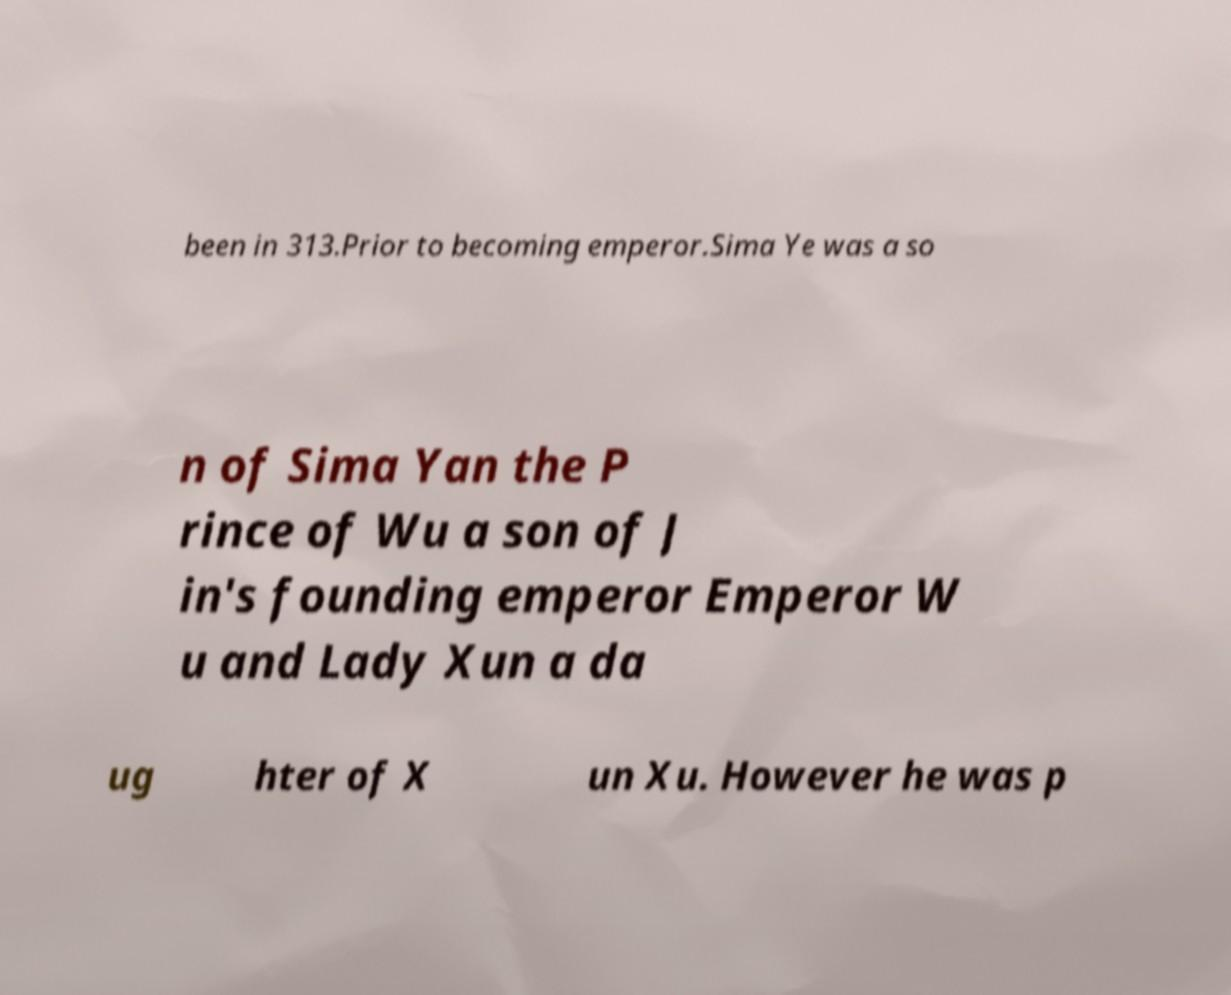For documentation purposes, I need the text within this image transcribed. Could you provide that? been in 313.Prior to becoming emperor.Sima Ye was a so n of Sima Yan the P rince of Wu a son of J in's founding emperor Emperor W u and Lady Xun a da ug hter of X un Xu. However he was p 